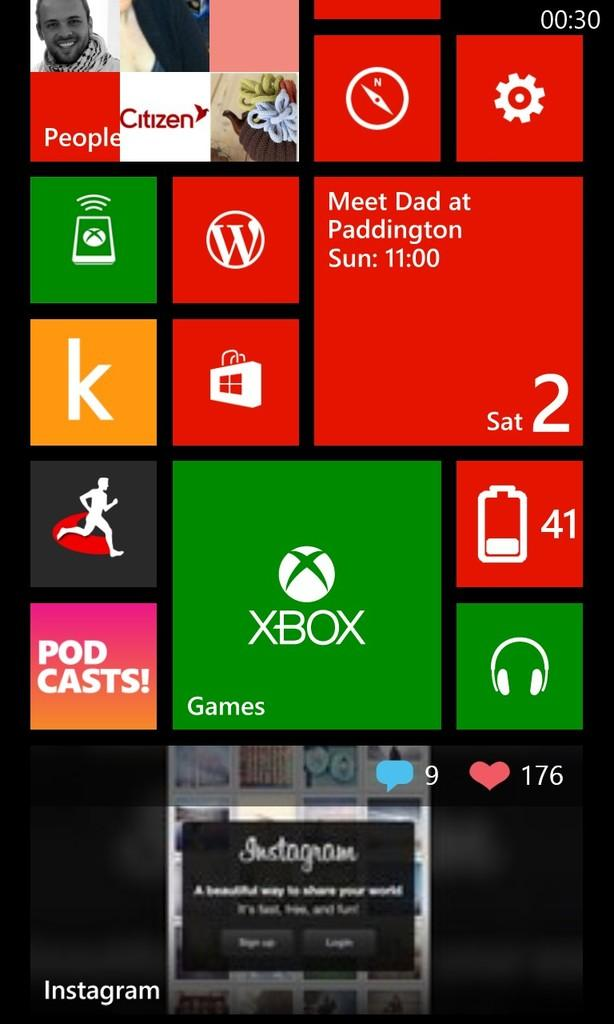Provide a one-sentence caption for the provided image. A screen with an x box logo, Instagram, A note that says meet dad a podcast and a music logo, games and battery percentage. 